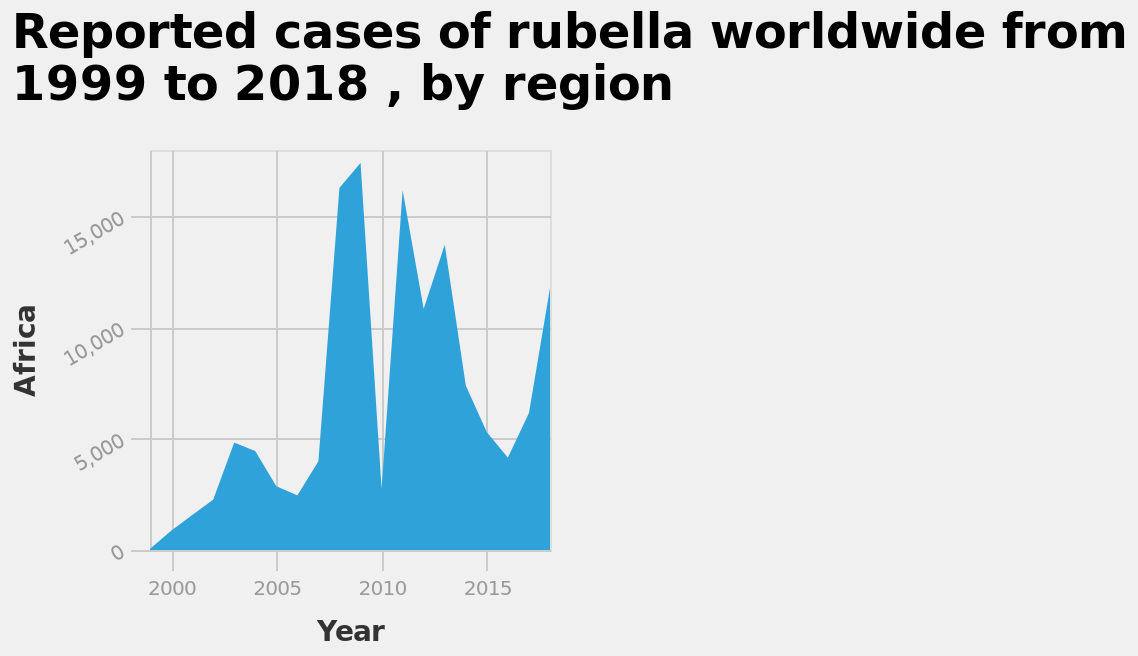<image>
What is marked on the x-axis of the diagram? The x-axis of the diagram is marked "Year" and has a linear scale ranging from 2000 to 2015. What was the highest number of cases recorded between 2006 and 2009? The highest number of cases recorded between 2006 and 2009 was around 18,000. 